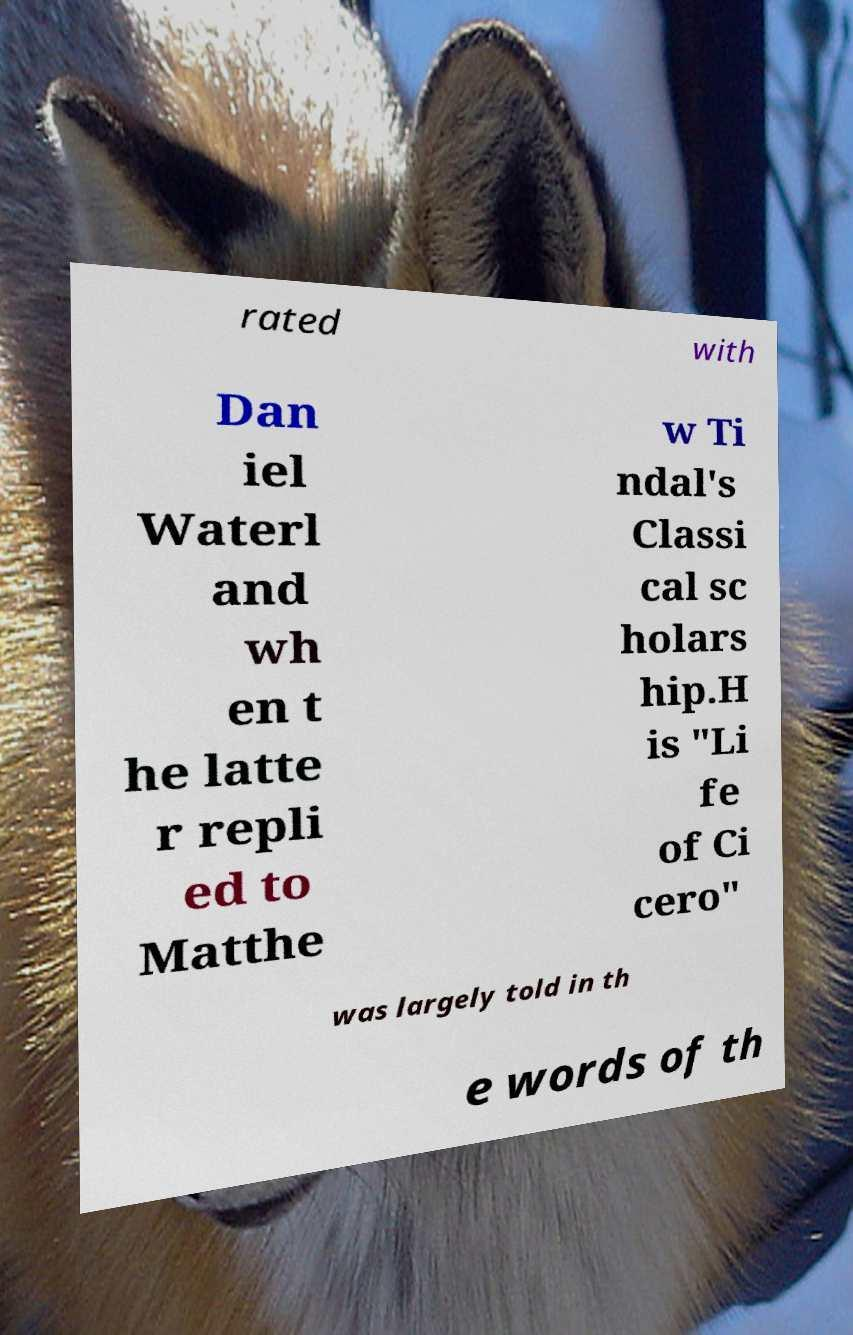There's text embedded in this image that I need extracted. Can you transcribe it verbatim? rated with Dan iel Waterl and wh en t he latte r repli ed to Matthe w Ti ndal's Classi cal sc holars hip.H is "Li fe of Ci cero" was largely told in th e words of th 